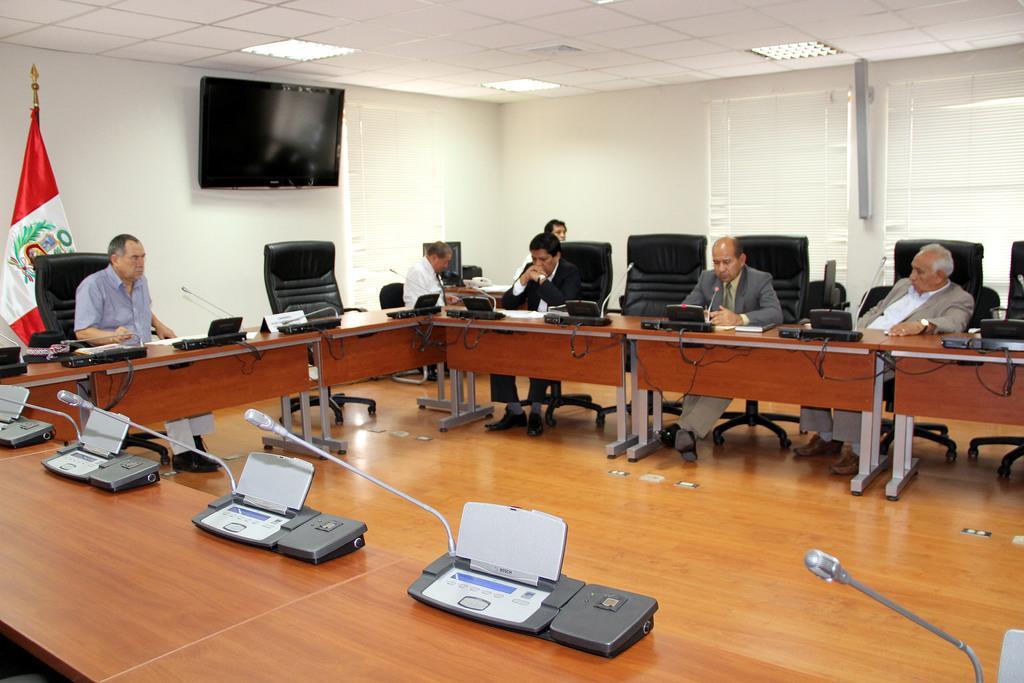Can you describe this image briefly? In this image I can see few people are sitting on chairs. On the table I can see mics. In the background I can see a flag and a television on this wall. 